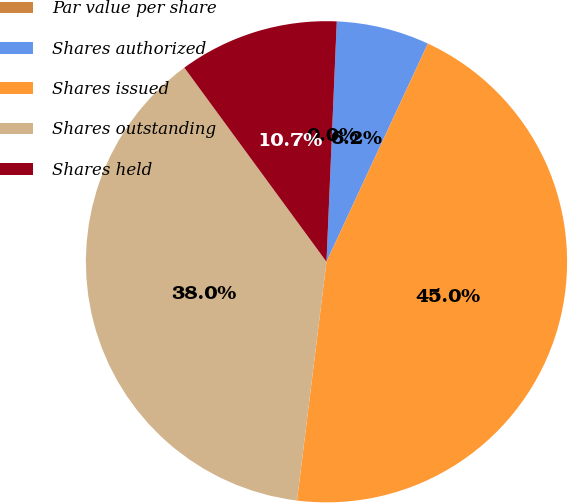Convert chart to OTSL. <chart><loc_0><loc_0><loc_500><loc_500><pie_chart><fcel>Par value per share<fcel>Shares authorized<fcel>Shares issued<fcel>Shares outstanding<fcel>Shares held<nl><fcel>0.0%<fcel>6.24%<fcel>45.03%<fcel>37.98%<fcel>10.74%<nl></chart> 